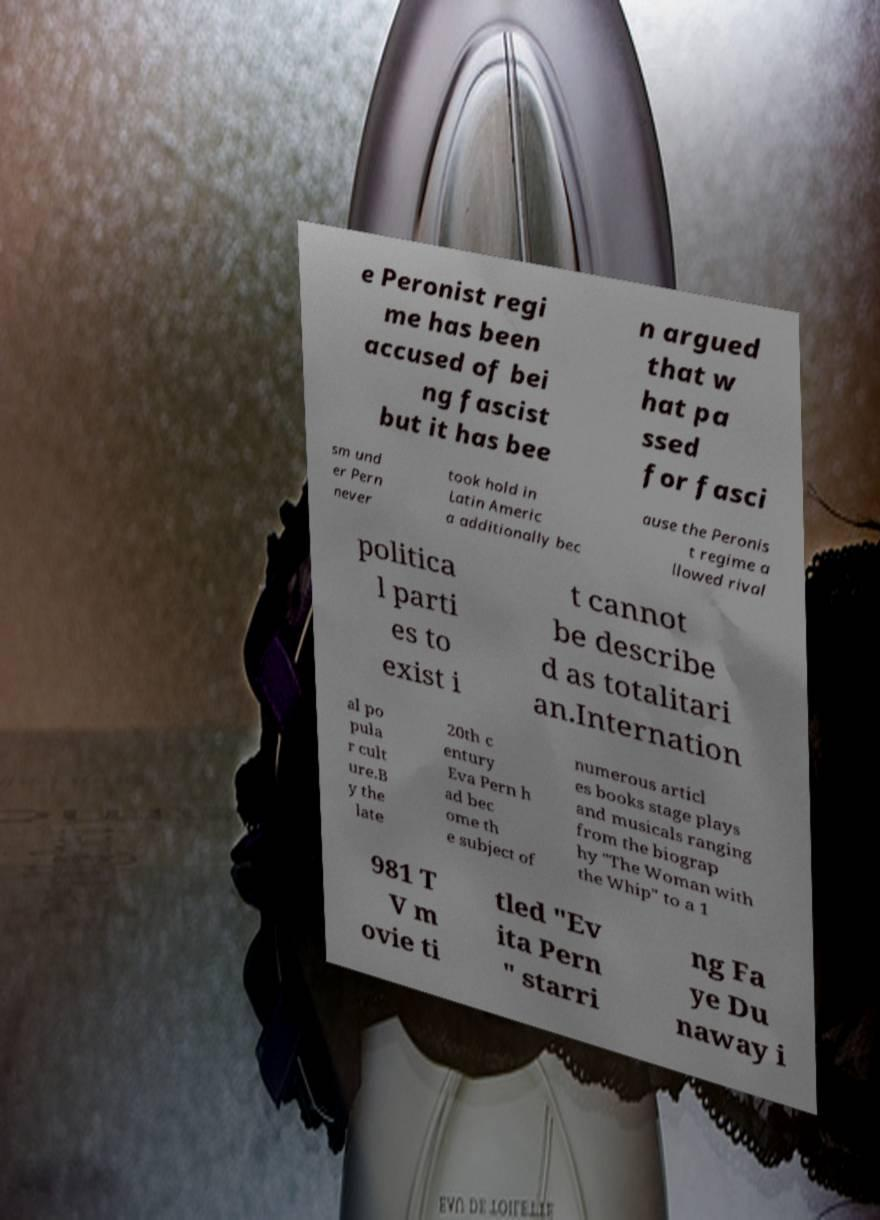Please identify and transcribe the text found in this image. e Peronist regi me has been accused of bei ng fascist but it has bee n argued that w hat pa ssed for fasci sm und er Pern never took hold in Latin Americ a additionally bec ause the Peronis t regime a llowed rival politica l parti es to exist i t cannot be describe d as totalitari an.Internation al po pula r cult ure.B y the late 20th c entury Eva Pern h ad bec ome th e subject of numerous articl es books stage plays and musicals ranging from the biograp hy "The Woman with the Whip" to a 1 981 T V m ovie ti tled "Ev ita Pern " starri ng Fa ye Du naway i 